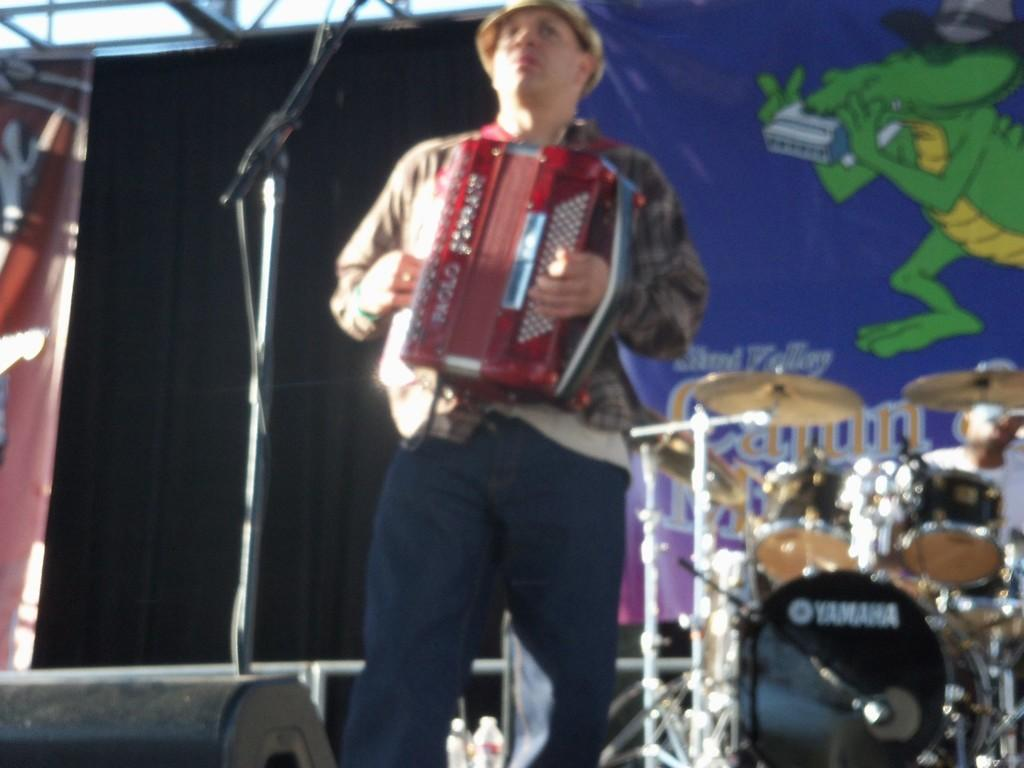What is the main subject of the image? There is a person standing in the image. What is the person doing in the image? The person is playing a musical instrument. What can be seen behind the person? The person is standing in front of a mic. Are there any other musical instruments in the image? Yes, there are other musical instruments in the image. What else is present in the image? There is a banner in the image. What type of plants can be seen growing on the banner in the image? There are no plants visible on the banner in the image. What is the end result of the person playing the musical instrument in the image? The image does not show the end result of the person playing the musical instrument; it only captures the moment of the person playing. 